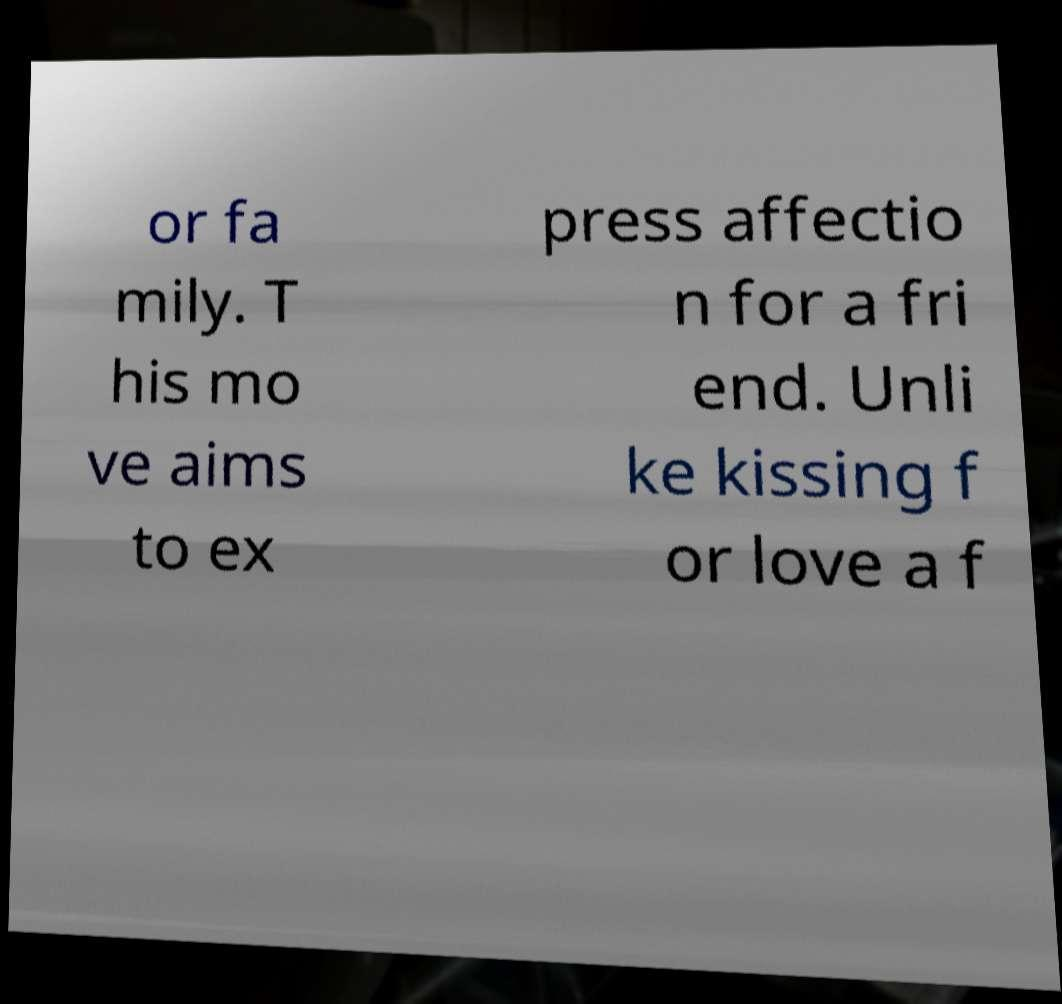For documentation purposes, I need the text within this image transcribed. Could you provide that? or fa mily. T his mo ve aims to ex press affectio n for a fri end. Unli ke kissing f or love a f 